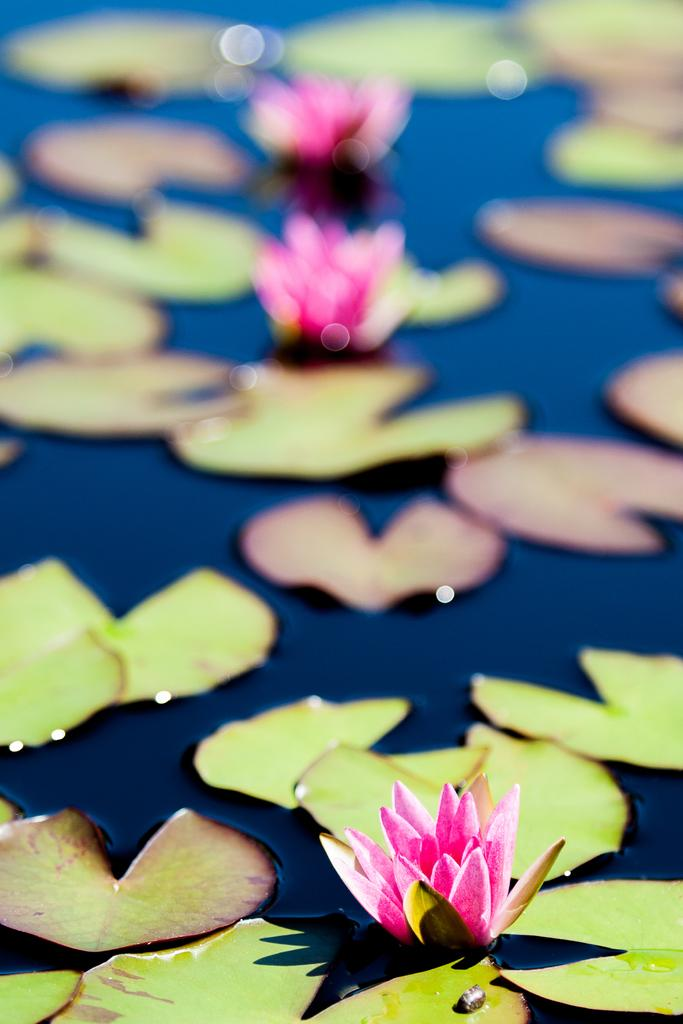What type of plants are visible in the image? There are lotuses in the image. What else can be seen in the image besides the lotuses? There are leaves in the image. Where are the lotuses and leaves located? The lotuses and leaves are on water. What type of stocking is visible on the tongue of the word in the image? There is no stocking, tongue, or word present in the image; it features lotuses and leaves on water. 